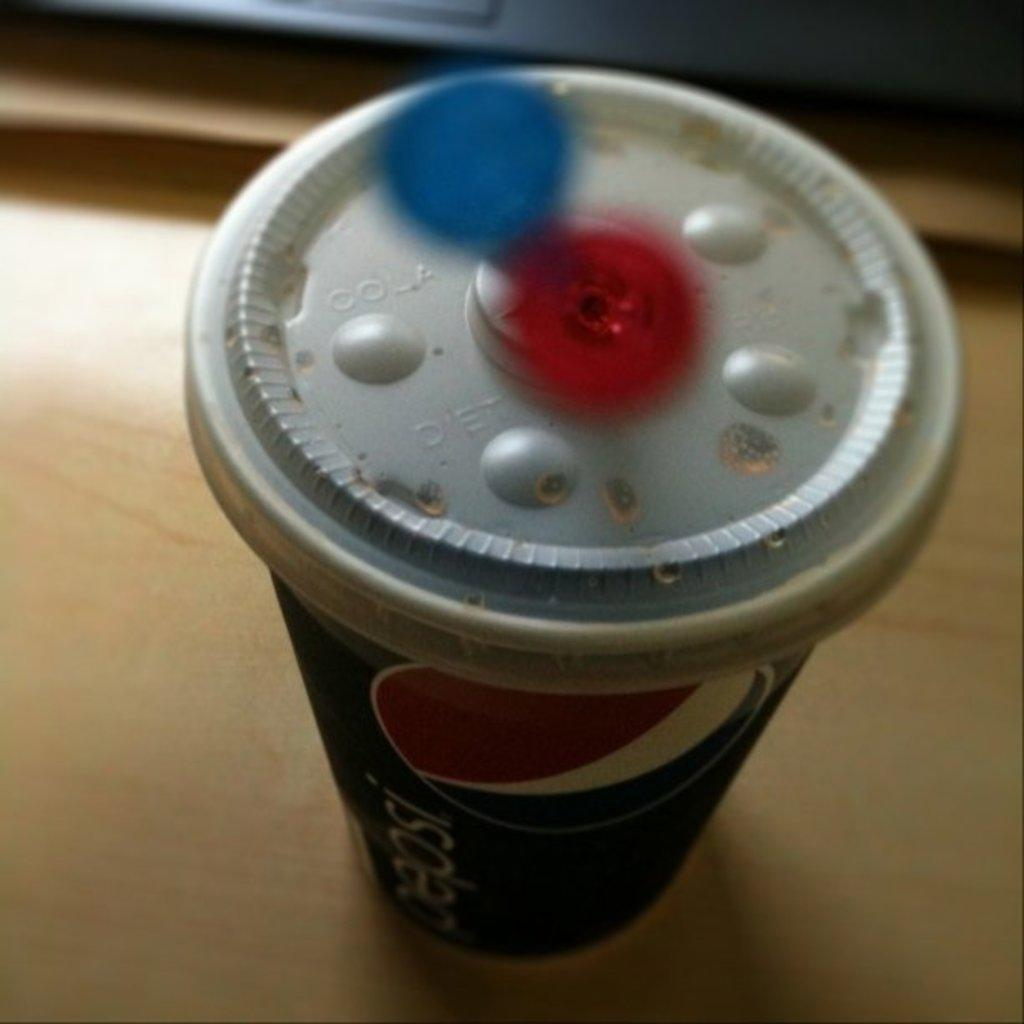What type of container is visible in the image? There is a disposal glass in the image. What can be seen in the background of the image? There is a table in the background of the image. What shape is the loaf of bread on the table in the image? There is no loaf of bread present in the image. What type of game is being played on the table in the image? There is no game being played on the table in the image. 